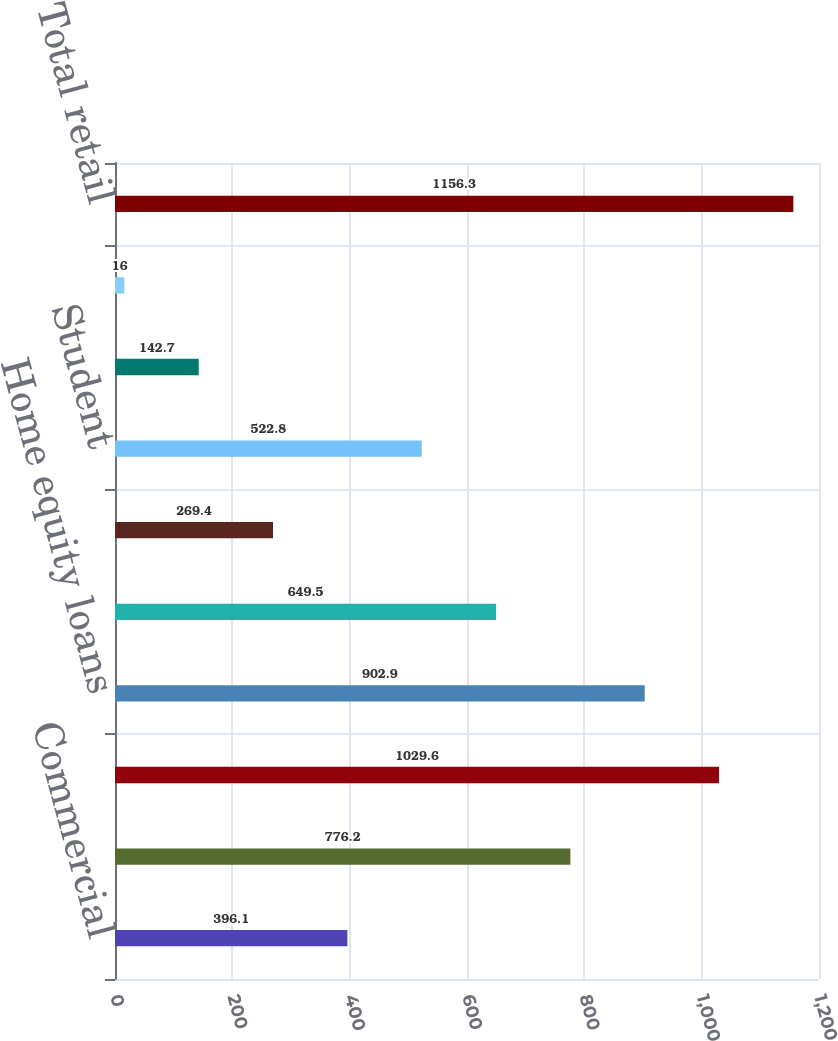<chart> <loc_0><loc_0><loc_500><loc_500><bar_chart><fcel>Commercial<fcel>Total commercial<fcel>Residential mortgages<fcel>Home equity loans<fcel>Home equity lines of credit<fcel>Home equity loans serviced by<fcel>Student<fcel>Credit cards<fcel>Other retail<fcel>Total retail<nl><fcel>396.1<fcel>776.2<fcel>1029.6<fcel>902.9<fcel>649.5<fcel>269.4<fcel>522.8<fcel>142.7<fcel>16<fcel>1156.3<nl></chart> 